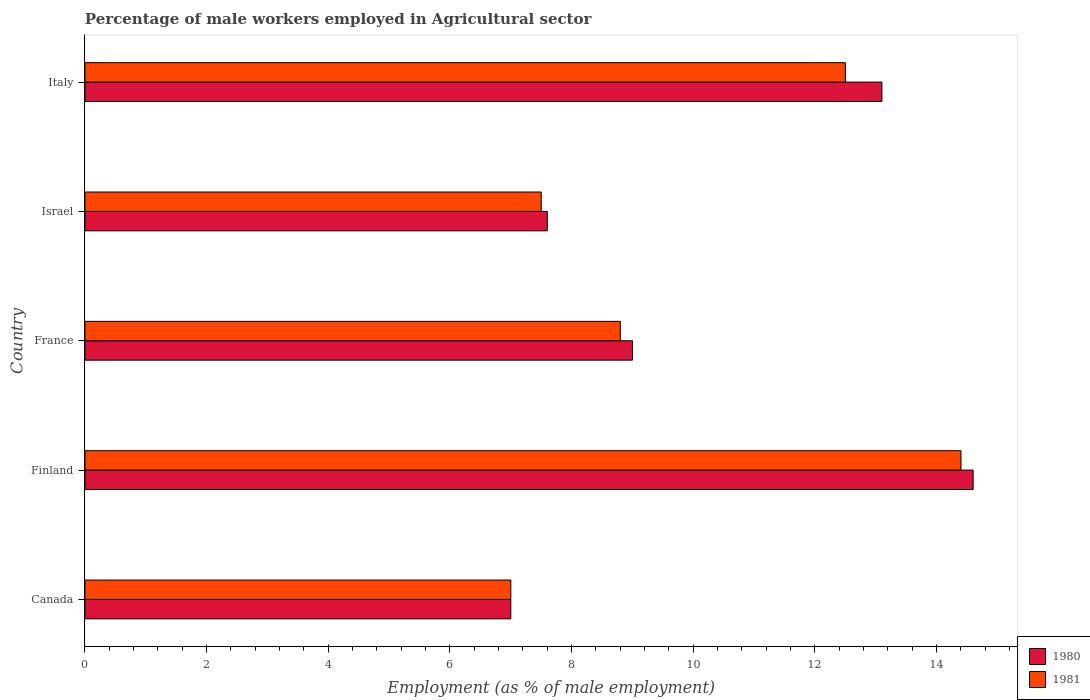How many different coloured bars are there?
Your response must be concise. 2. Are the number of bars per tick equal to the number of legend labels?
Give a very brief answer. Yes. Are the number of bars on each tick of the Y-axis equal?
Provide a short and direct response. Yes. How many bars are there on the 2nd tick from the top?
Your answer should be compact. 2. What is the percentage of male workers employed in Agricultural sector in 1981 in Finland?
Keep it short and to the point. 14.4. Across all countries, what is the maximum percentage of male workers employed in Agricultural sector in 1981?
Keep it short and to the point. 14.4. In which country was the percentage of male workers employed in Agricultural sector in 1980 minimum?
Offer a terse response. Canada. What is the total percentage of male workers employed in Agricultural sector in 1981 in the graph?
Offer a terse response. 50.2. What is the difference between the percentage of male workers employed in Agricultural sector in 1981 in Canada and that in Finland?
Ensure brevity in your answer.  -7.4. What is the difference between the percentage of male workers employed in Agricultural sector in 1981 in Finland and the percentage of male workers employed in Agricultural sector in 1980 in Italy?
Your answer should be very brief. 1.3. What is the average percentage of male workers employed in Agricultural sector in 1981 per country?
Your response must be concise. 10.04. What is the difference between the percentage of male workers employed in Agricultural sector in 1981 and percentage of male workers employed in Agricultural sector in 1980 in Italy?
Offer a very short reply. -0.6. In how many countries, is the percentage of male workers employed in Agricultural sector in 1981 greater than 0.8 %?
Keep it short and to the point. 5. What is the ratio of the percentage of male workers employed in Agricultural sector in 1981 in France to that in Italy?
Provide a succinct answer. 0.7. Is the difference between the percentage of male workers employed in Agricultural sector in 1981 in Finland and Israel greater than the difference between the percentage of male workers employed in Agricultural sector in 1980 in Finland and Israel?
Give a very brief answer. No. What is the difference between the highest and the lowest percentage of male workers employed in Agricultural sector in 1981?
Your answer should be very brief. 7.4. Is the sum of the percentage of male workers employed in Agricultural sector in 1981 in Israel and Italy greater than the maximum percentage of male workers employed in Agricultural sector in 1980 across all countries?
Provide a short and direct response. Yes. What does the 1st bar from the top in Italy represents?
Provide a succinct answer. 1981. What does the 2nd bar from the bottom in Israel represents?
Keep it short and to the point. 1981. How many bars are there?
Provide a succinct answer. 10. Does the graph contain grids?
Provide a short and direct response. No. How are the legend labels stacked?
Give a very brief answer. Vertical. What is the title of the graph?
Keep it short and to the point. Percentage of male workers employed in Agricultural sector. What is the label or title of the X-axis?
Offer a very short reply. Employment (as % of male employment). What is the label or title of the Y-axis?
Keep it short and to the point. Country. What is the Employment (as % of male employment) of 1980 in Finland?
Offer a terse response. 14.6. What is the Employment (as % of male employment) of 1981 in Finland?
Offer a very short reply. 14.4. What is the Employment (as % of male employment) of 1980 in France?
Your answer should be very brief. 9. What is the Employment (as % of male employment) in 1981 in France?
Provide a short and direct response. 8.8. What is the Employment (as % of male employment) in 1980 in Israel?
Offer a very short reply. 7.6. What is the Employment (as % of male employment) of 1980 in Italy?
Your answer should be very brief. 13.1. What is the Employment (as % of male employment) of 1981 in Italy?
Your answer should be compact. 12.5. Across all countries, what is the maximum Employment (as % of male employment) in 1980?
Your response must be concise. 14.6. Across all countries, what is the maximum Employment (as % of male employment) of 1981?
Provide a succinct answer. 14.4. Across all countries, what is the minimum Employment (as % of male employment) in 1980?
Your answer should be very brief. 7. Across all countries, what is the minimum Employment (as % of male employment) in 1981?
Provide a succinct answer. 7. What is the total Employment (as % of male employment) of 1980 in the graph?
Give a very brief answer. 51.3. What is the total Employment (as % of male employment) in 1981 in the graph?
Keep it short and to the point. 50.2. What is the difference between the Employment (as % of male employment) in 1980 in Canada and that in France?
Ensure brevity in your answer.  -2. What is the difference between the Employment (as % of male employment) in 1981 in Canada and that in France?
Make the answer very short. -1.8. What is the difference between the Employment (as % of male employment) of 1980 in Canada and that in Israel?
Make the answer very short. -0.6. What is the difference between the Employment (as % of male employment) in 1980 in Canada and that in Italy?
Provide a short and direct response. -6.1. What is the difference between the Employment (as % of male employment) in 1981 in Canada and that in Italy?
Your answer should be compact. -5.5. What is the difference between the Employment (as % of male employment) of 1980 in Finland and that in France?
Give a very brief answer. 5.6. What is the difference between the Employment (as % of male employment) in 1981 in Finland and that in France?
Offer a terse response. 5.6. What is the difference between the Employment (as % of male employment) in 1980 in Finland and that in Israel?
Your response must be concise. 7. What is the difference between the Employment (as % of male employment) in 1980 in Finland and that in Italy?
Provide a succinct answer. 1.5. What is the difference between the Employment (as % of male employment) in 1981 in Finland and that in Italy?
Your answer should be compact. 1.9. What is the difference between the Employment (as % of male employment) of 1981 in France and that in Italy?
Offer a very short reply. -3.7. What is the difference between the Employment (as % of male employment) in 1980 in Israel and that in Italy?
Provide a succinct answer. -5.5. What is the difference between the Employment (as % of male employment) of 1980 in Canada and the Employment (as % of male employment) of 1981 in Finland?
Your response must be concise. -7.4. What is the difference between the Employment (as % of male employment) of 1980 in Canada and the Employment (as % of male employment) of 1981 in Israel?
Make the answer very short. -0.5. What is the difference between the Employment (as % of male employment) in 1980 in Finland and the Employment (as % of male employment) in 1981 in France?
Your answer should be very brief. 5.8. What is the difference between the Employment (as % of male employment) in 1980 in Finland and the Employment (as % of male employment) in 1981 in Israel?
Provide a short and direct response. 7.1. What is the difference between the Employment (as % of male employment) of 1980 in France and the Employment (as % of male employment) of 1981 in Italy?
Provide a succinct answer. -3.5. What is the difference between the Employment (as % of male employment) in 1980 in Israel and the Employment (as % of male employment) in 1981 in Italy?
Your answer should be very brief. -4.9. What is the average Employment (as % of male employment) of 1980 per country?
Your answer should be very brief. 10.26. What is the average Employment (as % of male employment) in 1981 per country?
Make the answer very short. 10.04. What is the difference between the Employment (as % of male employment) in 1980 and Employment (as % of male employment) in 1981 in Finland?
Your response must be concise. 0.2. What is the difference between the Employment (as % of male employment) in 1980 and Employment (as % of male employment) in 1981 in Italy?
Provide a short and direct response. 0.6. What is the ratio of the Employment (as % of male employment) in 1980 in Canada to that in Finland?
Make the answer very short. 0.48. What is the ratio of the Employment (as % of male employment) of 1981 in Canada to that in Finland?
Offer a very short reply. 0.49. What is the ratio of the Employment (as % of male employment) of 1981 in Canada to that in France?
Keep it short and to the point. 0.8. What is the ratio of the Employment (as % of male employment) of 1980 in Canada to that in Israel?
Your answer should be compact. 0.92. What is the ratio of the Employment (as % of male employment) in 1980 in Canada to that in Italy?
Your answer should be compact. 0.53. What is the ratio of the Employment (as % of male employment) in 1981 in Canada to that in Italy?
Your answer should be very brief. 0.56. What is the ratio of the Employment (as % of male employment) of 1980 in Finland to that in France?
Provide a short and direct response. 1.62. What is the ratio of the Employment (as % of male employment) of 1981 in Finland to that in France?
Your answer should be compact. 1.64. What is the ratio of the Employment (as % of male employment) of 1980 in Finland to that in Israel?
Provide a succinct answer. 1.92. What is the ratio of the Employment (as % of male employment) in 1981 in Finland to that in Israel?
Provide a succinct answer. 1.92. What is the ratio of the Employment (as % of male employment) of 1980 in Finland to that in Italy?
Make the answer very short. 1.11. What is the ratio of the Employment (as % of male employment) of 1981 in Finland to that in Italy?
Your answer should be compact. 1.15. What is the ratio of the Employment (as % of male employment) of 1980 in France to that in Israel?
Provide a succinct answer. 1.18. What is the ratio of the Employment (as % of male employment) in 1981 in France to that in Israel?
Your answer should be very brief. 1.17. What is the ratio of the Employment (as % of male employment) of 1980 in France to that in Italy?
Offer a terse response. 0.69. What is the ratio of the Employment (as % of male employment) of 1981 in France to that in Italy?
Your answer should be very brief. 0.7. What is the ratio of the Employment (as % of male employment) in 1980 in Israel to that in Italy?
Your answer should be compact. 0.58. What is the ratio of the Employment (as % of male employment) in 1981 in Israel to that in Italy?
Ensure brevity in your answer.  0.6. What is the difference between the highest and the second highest Employment (as % of male employment) of 1980?
Ensure brevity in your answer.  1.5. What is the difference between the highest and the second highest Employment (as % of male employment) in 1981?
Ensure brevity in your answer.  1.9. What is the difference between the highest and the lowest Employment (as % of male employment) in 1980?
Your answer should be compact. 7.6. What is the difference between the highest and the lowest Employment (as % of male employment) of 1981?
Give a very brief answer. 7.4. 